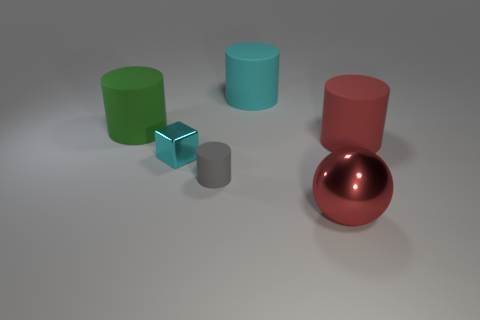Subtract all large red cylinders. How many cylinders are left? 3 Subtract all cyan cylinders. How many cylinders are left? 3 Add 3 red metal spheres. How many objects exist? 9 Subtract all cylinders. How many objects are left? 2 Subtract all blue cylinders. Subtract all yellow spheres. How many cylinders are left? 4 Subtract all large things. Subtract all big gray matte cylinders. How many objects are left? 2 Add 3 large shiny balls. How many large shiny balls are left? 4 Add 4 big matte objects. How many big matte objects exist? 7 Subtract 0 purple balls. How many objects are left? 6 